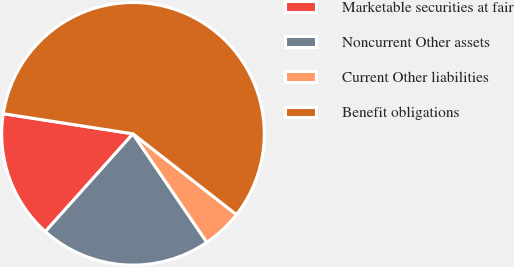Convert chart to OTSL. <chart><loc_0><loc_0><loc_500><loc_500><pie_chart><fcel>Marketable securities at fair<fcel>Noncurrent Other assets<fcel>Current Other liabilities<fcel>Benefit obligations<nl><fcel>15.82%<fcel>21.14%<fcel>4.94%<fcel>58.1%<nl></chart> 